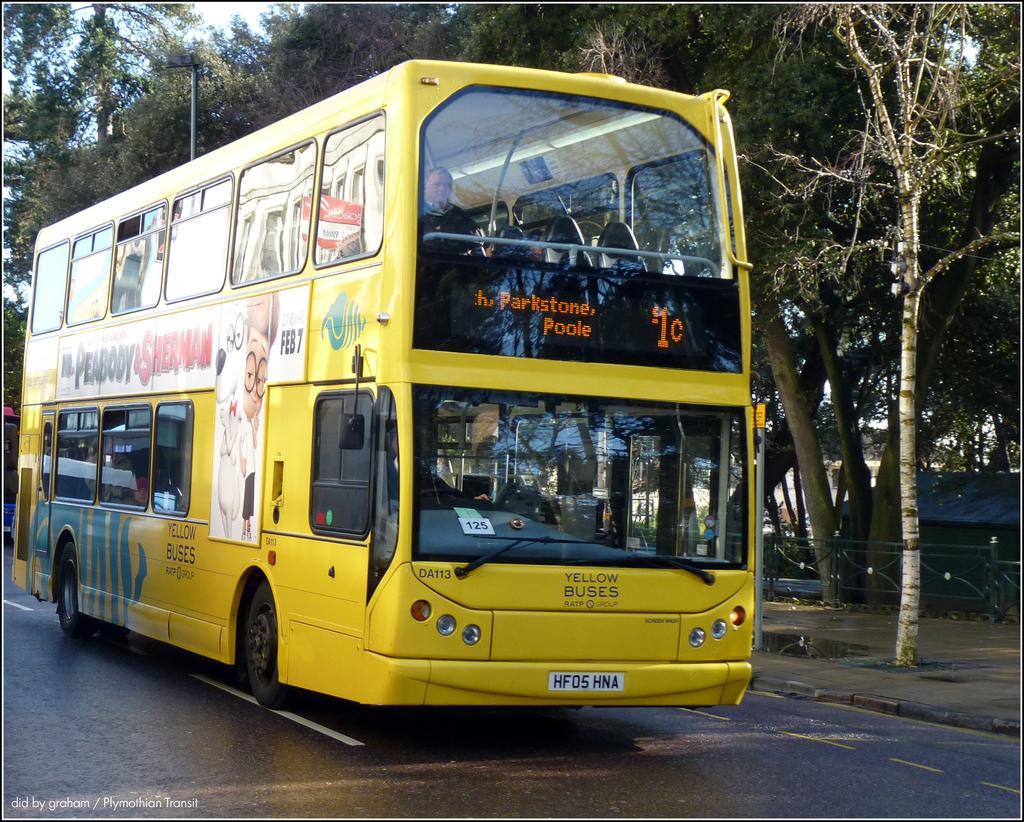Describe this image in one or two sentences. In this image we can see a bus on the road. In the background there are trees and sky. We can see a pole and there is a railing. 